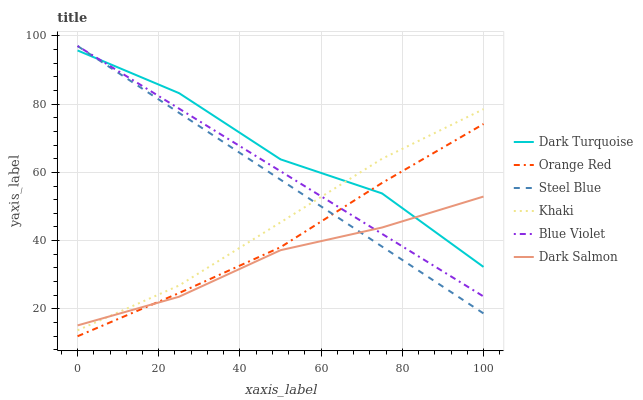Does Dark Salmon have the minimum area under the curve?
Answer yes or no. Yes. Does Dark Turquoise have the maximum area under the curve?
Answer yes or no. Yes. Does Dark Turquoise have the minimum area under the curve?
Answer yes or no. No. Does Dark Salmon have the maximum area under the curve?
Answer yes or no. No. Is Steel Blue the smoothest?
Answer yes or no. Yes. Is Dark Turquoise the roughest?
Answer yes or no. Yes. Is Dark Salmon the smoothest?
Answer yes or no. No. Is Dark Salmon the roughest?
Answer yes or no. No. Does Orange Red have the lowest value?
Answer yes or no. Yes. Does Dark Salmon have the lowest value?
Answer yes or no. No. Does Blue Violet have the highest value?
Answer yes or no. Yes. Does Dark Turquoise have the highest value?
Answer yes or no. No. Is Orange Red less than Khaki?
Answer yes or no. Yes. Is Khaki greater than Orange Red?
Answer yes or no. Yes. Does Dark Salmon intersect Blue Violet?
Answer yes or no. Yes. Is Dark Salmon less than Blue Violet?
Answer yes or no. No. Is Dark Salmon greater than Blue Violet?
Answer yes or no. No. Does Orange Red intersect Khaki?
Answer yes or no. No. 